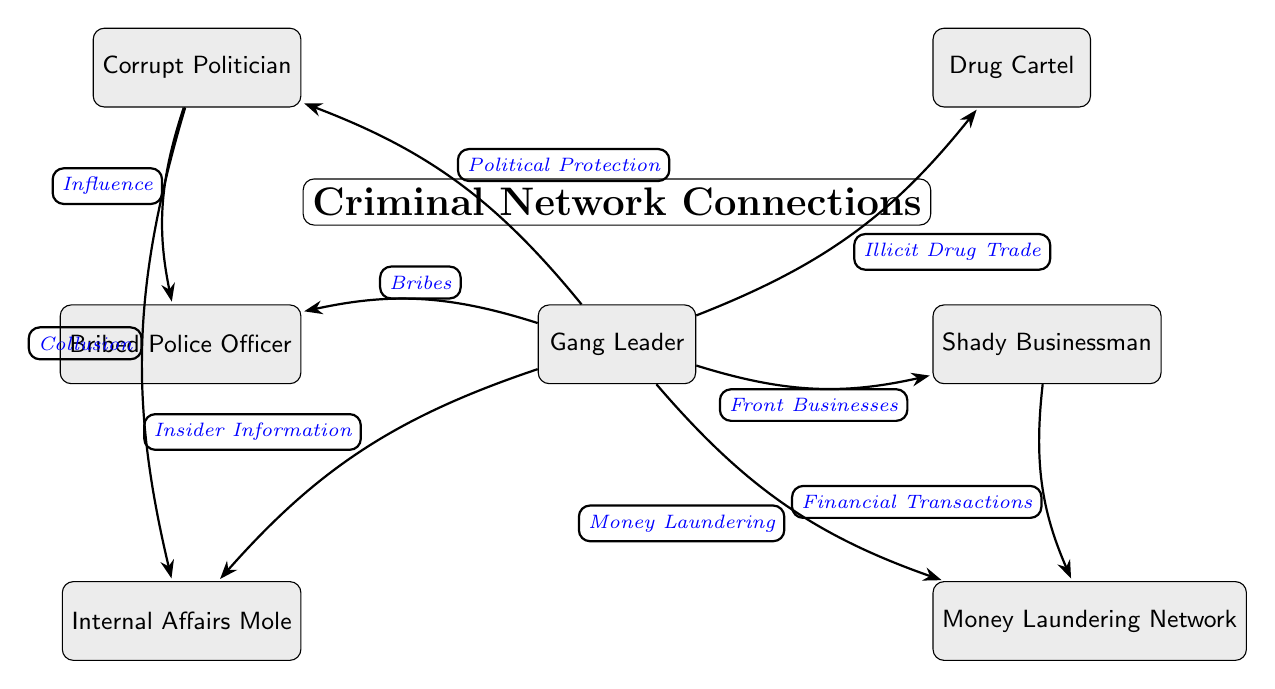What is the first node connected to the Gang Leader? The first node connected to the Gang Leader in the diagram is identifiable by its position directly connected with an edge labeled "Illicit Drug Trade". This connection leads to the Drug Cartel node, which is placed above right of the Gang Leader.
Answer: Drug Cartel How many connections does the Gang Leader have? By counting the edges that originate from the Gang Leader, we can determine the number of connections. The Gang Leader has connections to six nodes, each representing different illegal activities or entities.
Answer: 6 What type of illegal activity connects the Gang Leader to Law Enforcement? The Gang Leader is connected to the Law Enforcement node labeled "Bribed Police Officer" via the edge labeled "Bribes". This indicates that bribery is the illegal activity in question.
Answer: Bribes Which node is associated with "Influence"? To find the node associated with "Influence," we look at the connections emanating from the Corrupt Politician. The edge drawn from the Politician to the Law Enforcement node explicitly states "Influence". Hence, the linked node is the bribed police officer.
Answer: Bribed Police Officer What is the relationship between Businessman and Money Laundering Network? The Businessman node connects to the Money Laundering Network through the edge labeled "Financial Transactions". This entails a direct link between financial dealings of the businessman and the money laundering entity.
Answer: Financial Transactions Which two law enforcement entities are connected to the Gang Leader? Observing the direct connections from the Gang Leader, there are two law enforcement entities specified on the left side of the diagram: the Bribed Police Officer and Internal Affairs Mole. Both nodes are connected through different activities.
Answer: Bribed Police Officer, Internal Affairs Mole How does the Politician maintain influence over law enforcement? There is a connection labeled "Collusion" from the Corrupt Politician to the Internal Affairs Mole, suggesting that this corrupt politician exerts influence over law enforcement through a colluding relationship, effectively positioning them in a compromising situation.
Answer: Collusion What is indicated by the edge "Insider Information"? This edge connects the Gang Leader to the Internal Affairs Mole, which implies that the Gang Leader is possibly receiving inside information regarding law enforcement activities or investigations. Thus, the edge signifies a transfer of illicitly gained information.
Answer: Insider Information Which criminal organization is associated with the Gang Leader for drug-related activities? The connection specified by "Illicit Drug Trade" draws attention to the Drug Cartel as the criminal organization that the Gang Leader collaborates with for drug-related activities. This information is visually represented in the diagram.
Answer: Drug Cartel 